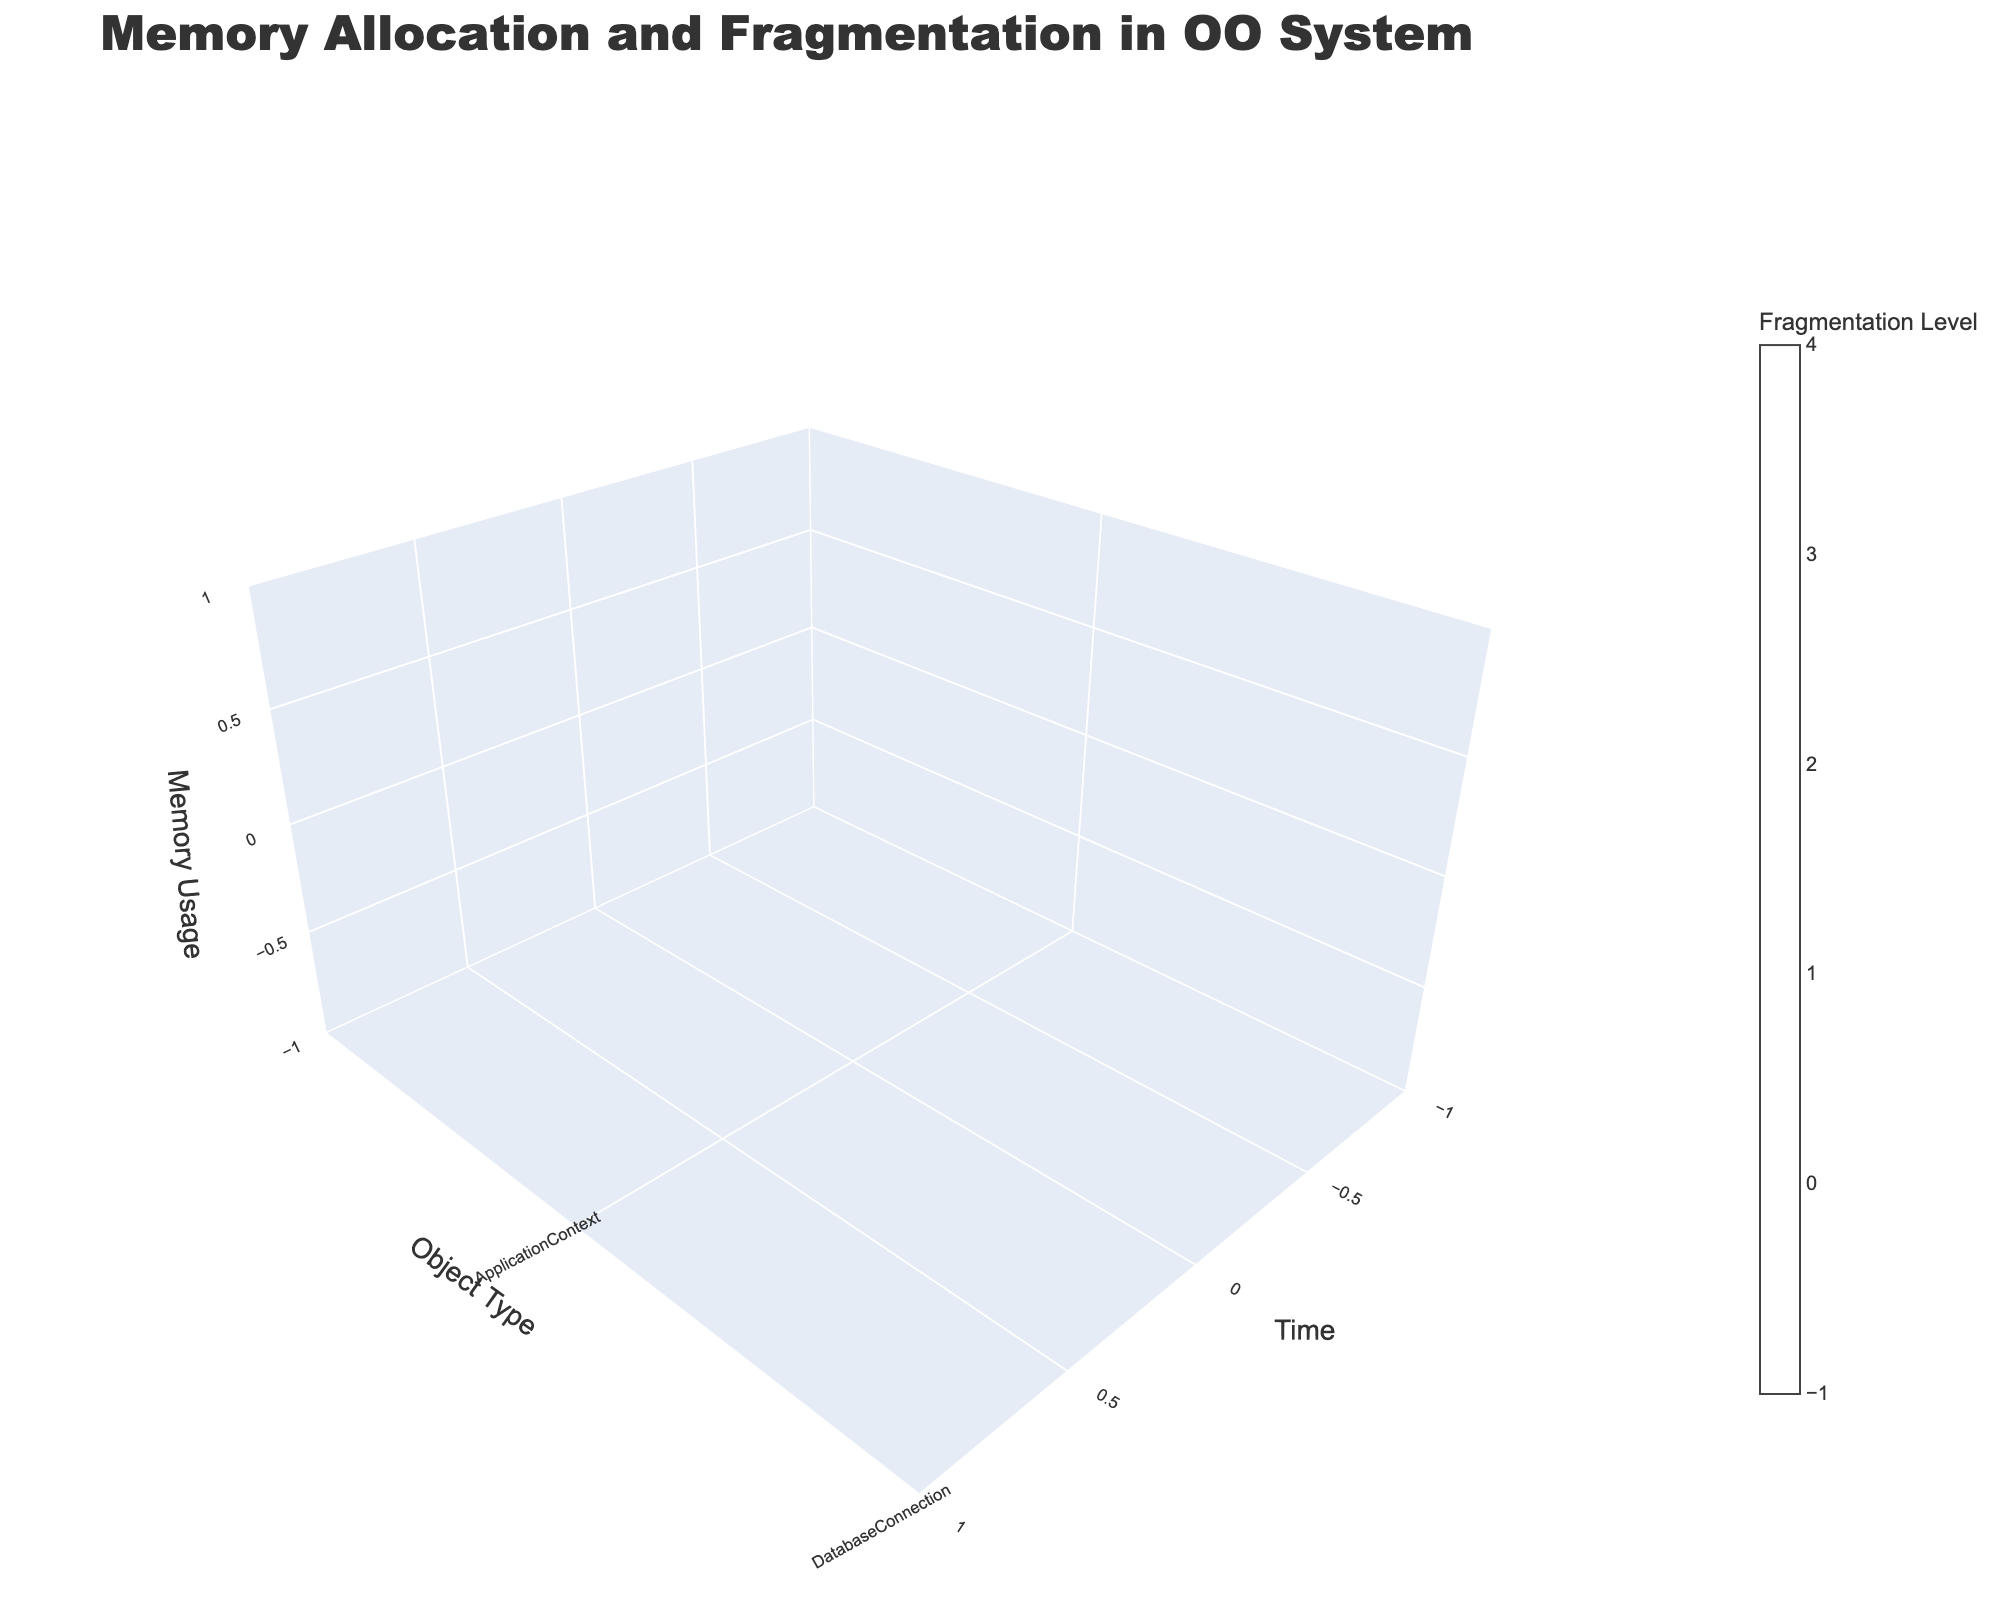What's the title of the plot? The title is displayed prominently at the top of the plot. By looking at the plot, you can read the title text.
Answer: Memory Allocation and Fragmentation in OO System What does the x-axis represent in the figure? The x-axis label is visible on the plot, typically along the bottom axis. It clearly specifies what the x-axis represents.
Answer: Time Which object type has the highest memory usage at time 6? Locate the time point 6 on the x-axis, then look at the corresponding y-axis (object type) and z-axis (memory usage) values. Identify which object has the highest z value at x=6.
Answer: ImageProcessor How does the fragmentation level of CacheManager change from time 8 to time 28? Observe the colors representing fragmentation levels for CacheManager at time 8 and 28. Compare the color intensities or numerical values to determine the change.
Answer: Decreases from 7 to 6 Is there a point where UserSession and ApplicationContext have the same memory usage? Compare the z-axis values (memory usage) for UserSession and ApplicationContext at each time point to see if they ever match.
Answer: Yes, at time 24 Which object type experiences a decrease in memory usage and fragmentation level over time? For each object type, examine the trend of z-axis (memory usage) and color intensity (fragmentation level) over time. Identify the one that shows decreasing values.
Answer: ApplicationContext What is the average memory usage of ImageProcessor over the recorded time points? Add up the z-axis values for ImageProcessor and divide by the number of time points recorded for this object type.
Answer: (40 + 38) / 2 = 39 How does the fragmentation level of SecurityModule at time 12 compare to the fragmentation level of ThreadPool at time 18? Look at the color representing fragmentation levels for SecurityModule at time 12 and ThreadPool at time 18, and compare their intensities or numerical values.
Answer: SecurityModule has a higher fragmentation level of 10 compared to ThreadPool's 5 What is the total memory usage by DatabaseConnection over all recorded time points? Sum the z-axis values (memory usage) for DatabaseConnection across all its recorded time points.
Answer: 25 + 22 = 47 